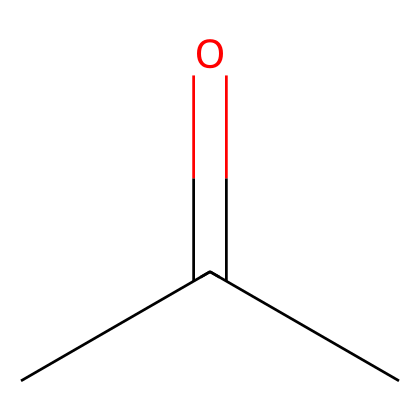What is the name of this chemical? The SMILES representation "CC(=O)C" corresponds to acetone, which is a well-known solvent. Therefore, by recognizing the structure from its SMILES notation, we can name the chemical.
Answer: acetone How many carbon atoms are in acetone? Looking at the SMILES notation "CC(=O)C", we note there are three 'C' symbols, indicating three carbon atoms in the structure.
Answer: three What is the functional group present in acetone? In the SMILES "CC(=O)C", the "=O" indicates a carbonyl group, which is characteristic of ketone functional groups. Since acetone is a type of ketone, this is the functional group present.
Answer: carbonyl What is the total number of hydrogen atoms in acetone? Each carbon typically bonds with enough hydrogen atoms to complete its tetravalence. In acetone, there are three carbons. The end carbon (CH3) has three hydrogens, the middle carbon (C=O) does not have attached hydrogens, and the other end carbon (CH3) also has three hydrogens. Therefore, adding them together gives a total of six hydrogen atoms.
Answer: six Is acetone a polar or non-polar solvent? Acetone contains a carbonyl group which makes it polar due to the electronegativity difference between carbon and oxygen. This polar nature allows acetone to interact effectively with various solutes, indicating that it acts as a polar solvent.
Answer: polar What property of acetone allows it to be an effective solvent for cleaning? The polar nature of acetone, combined with its ability to dissolve both polar and non-polar substances, enhances its effectiveness as a cleaning agent, especially in removing dirt and residues found on basketball courts.
Answer: solubility 